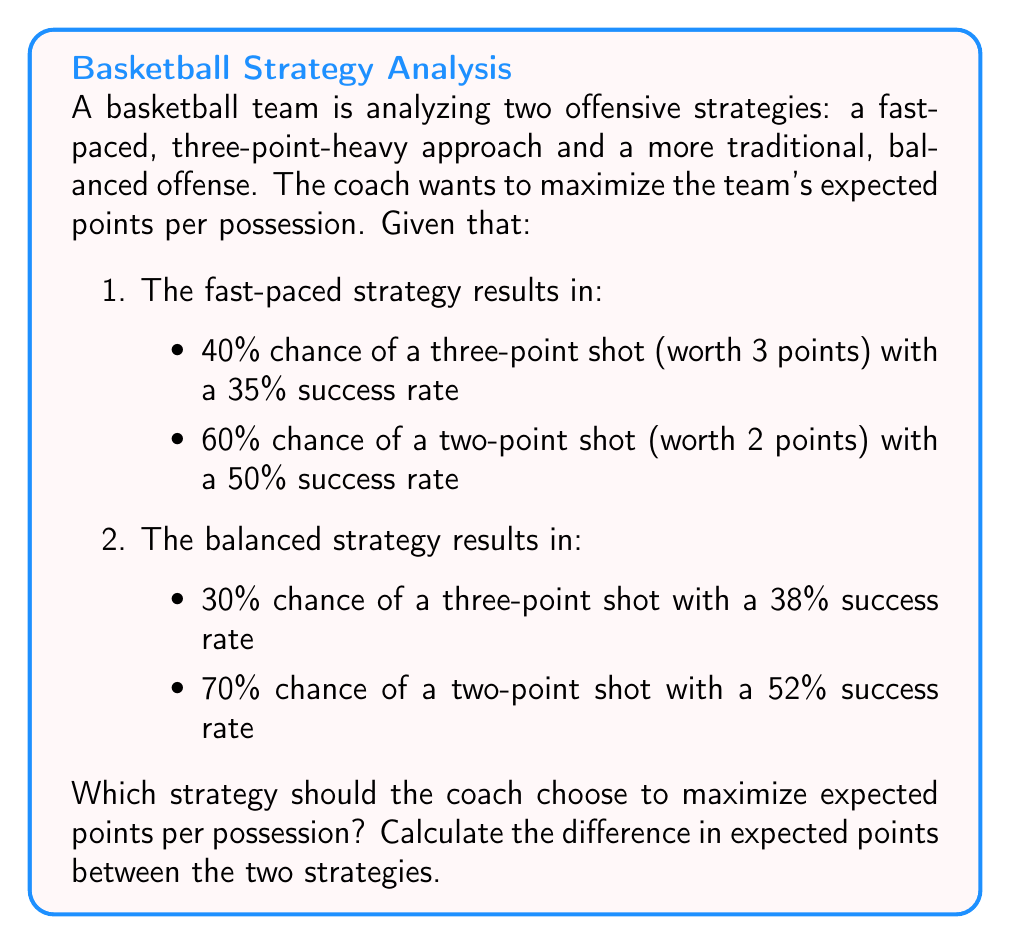Provide a solution to this math problem. Let's approach this step-by-step using probability and expected value calculations:

1. Fast-paced strategy:
   a) Expected points from three-point shots:
      $$E_{3pt} = 0.40 \times 3 \times 0.35 = 0.42$$
   b) Expected points from two-point shots:
      $$E_{2pt} = 0.60 \times 2 \times 0.50 = 0.60$$
   c) Total expected points per possession:
      $$E_{fast} = E_{3pt} + E_{2pt} = 0.42 + 0.60 = 1.02$$

2. Balanced strategy:
   a) Expected points from three-point shots:
      $$E_{3pt} = 0.30 \times 3 \times 0.38 = 0.342$$
   b) Expected points from two-point shots:
      $$E_{2pt} = 0.70 \times 2 \times 0.52 = 0.728$$
   c) Total expected points per possession:
      $$E_{balanced} = E_{3pt} + E_{2pt} = 0.342 + 0.728 = 1.07$$

3. Difference in expected points:
   $$\Delta E = E_{balanced} - E_{fast} = 1.07 - 1.02 = 0.05$$

The balanced strategy yields 0.05 more expected points per possession than the fast-paced strategy.
Answer: Choose balanced strategy; 0.05 points difference 